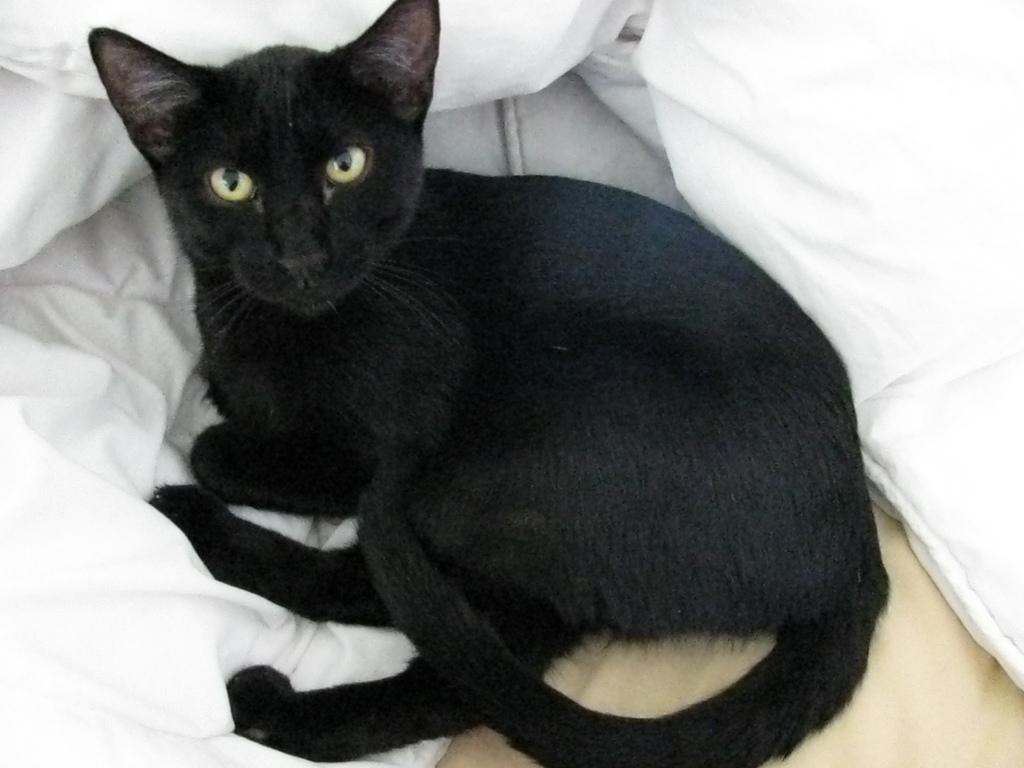In one or two sentences, can you explain what this image depicts? In this image we can see a black color cat on the bed. We can also see the white blanket. 